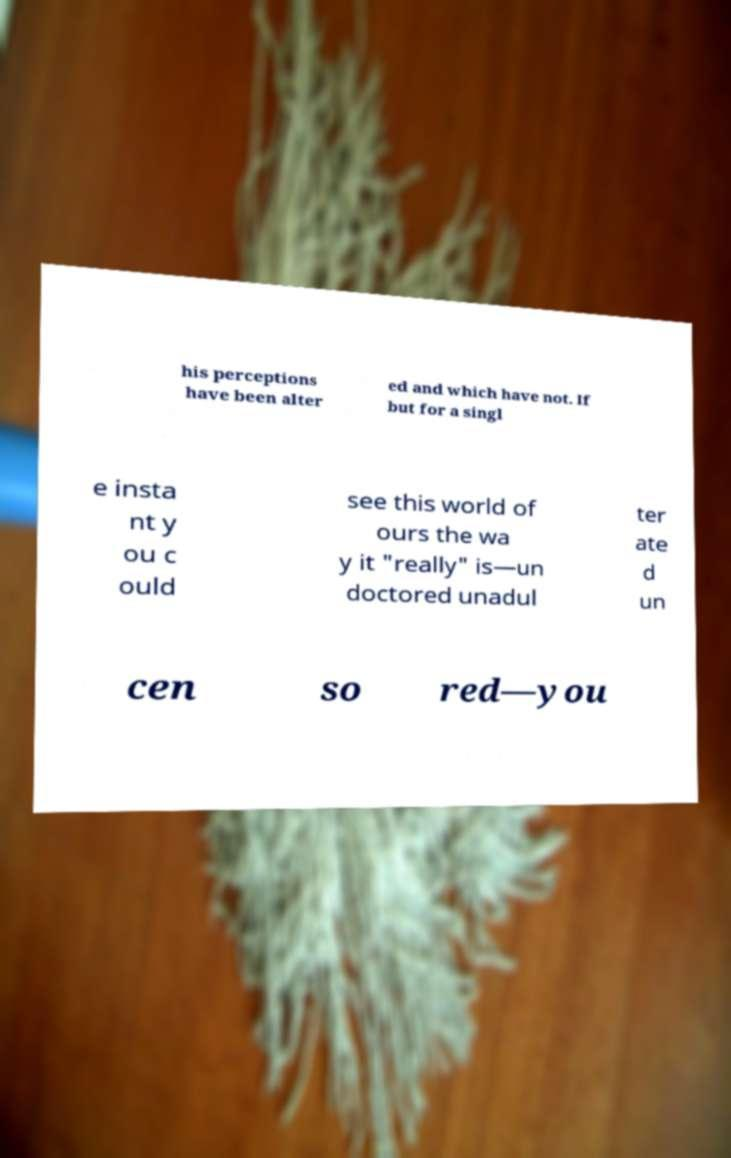I need the written content from this picture converted into text. Can you do that? his perceptions have been alter ed and which have not. If but for a singl e insta nt y ou c ould see this world of ours the wa y it "really" is—un doctored unadul ter ate d un cen so red—you 